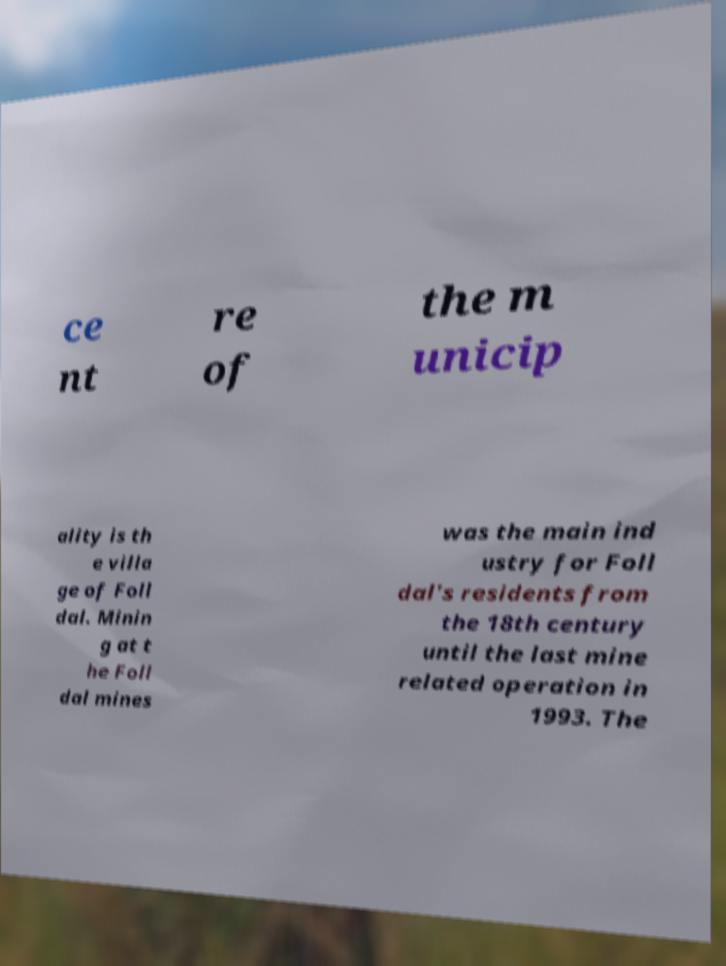What messages or text are displayed in this image? I need them in a readable, typed format. ce nt re of the m unicip ality is th e villa ge of Foll dal. Minin g at t he Foll dal mines was the main ind ustry for Foll dal's residents from the 18th century until the last mine related operation in 1993. The 